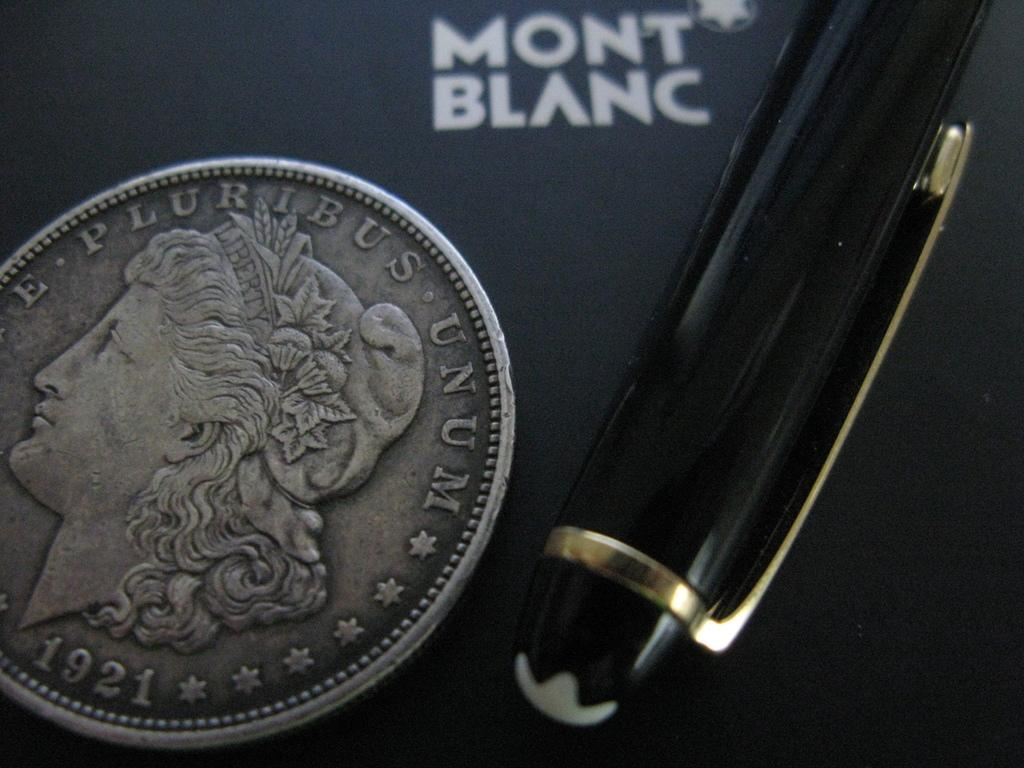<image>
Share a concise interpretation of the image provided. A 1921 coin and a pen on a paper advertising Mont Blanc. 